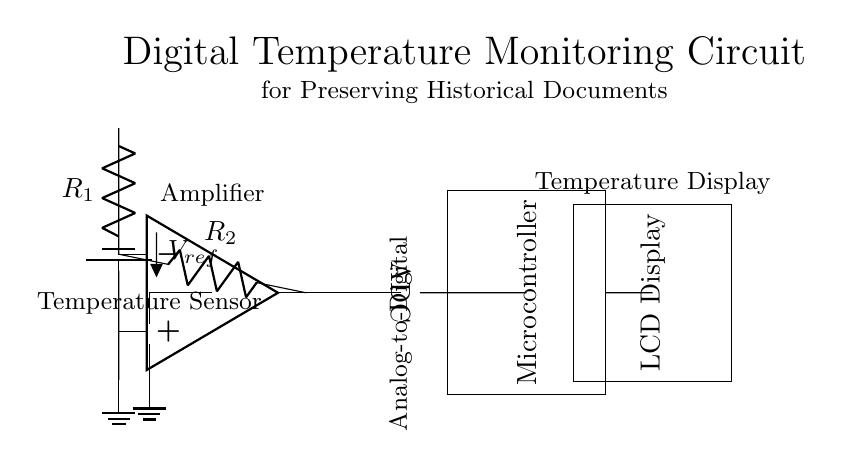What component is used to sense temperature? The circuit uses a thermistor as the temperature sensing component. This is indicated at the beginning of the circuit diagram where the thermistor is used as the first element.
Answer: thermistor What is the role of the operational amplifier? The operational amplifier acts as an amplifier in the circuit, boosting the signal from the thermistor and ensuring adequate voltage is supplied for the ADC. The diagram shows the op amp connected directly to the thermistor and voltage divider.
Answer: amplifier What type of display is used to show the temperature? An LCD display is used to present the temperature readings from the microcontroller. This is clearly labeled in the circuit diagram.
Answer: LCD Display What is the reference voltage in the voltage divider? The reference voltage is denoted as V reference in the circuit diagram, which is a crucial part of the voltage divider that ensures a stable input to the operational amplifier.
Answer: V reference How is the temperature signal converted in the circuit? The temperature signal from the op amp is fed into an ADC, where it is converted from an analog signal to a digital format that the microcontroller can process. This workflow is represented in the connections between the op amp and the ADC.
Answer: ADC What is the purpose of the microcontroller in this circuit? The microcontroller processes the digital signal received from the ADC and controls the output to the LCD display, allowing the temperature readings to be shown. The circuit shows this clear flow from the ADC to the microcontroller.
Answer: microcontroller 